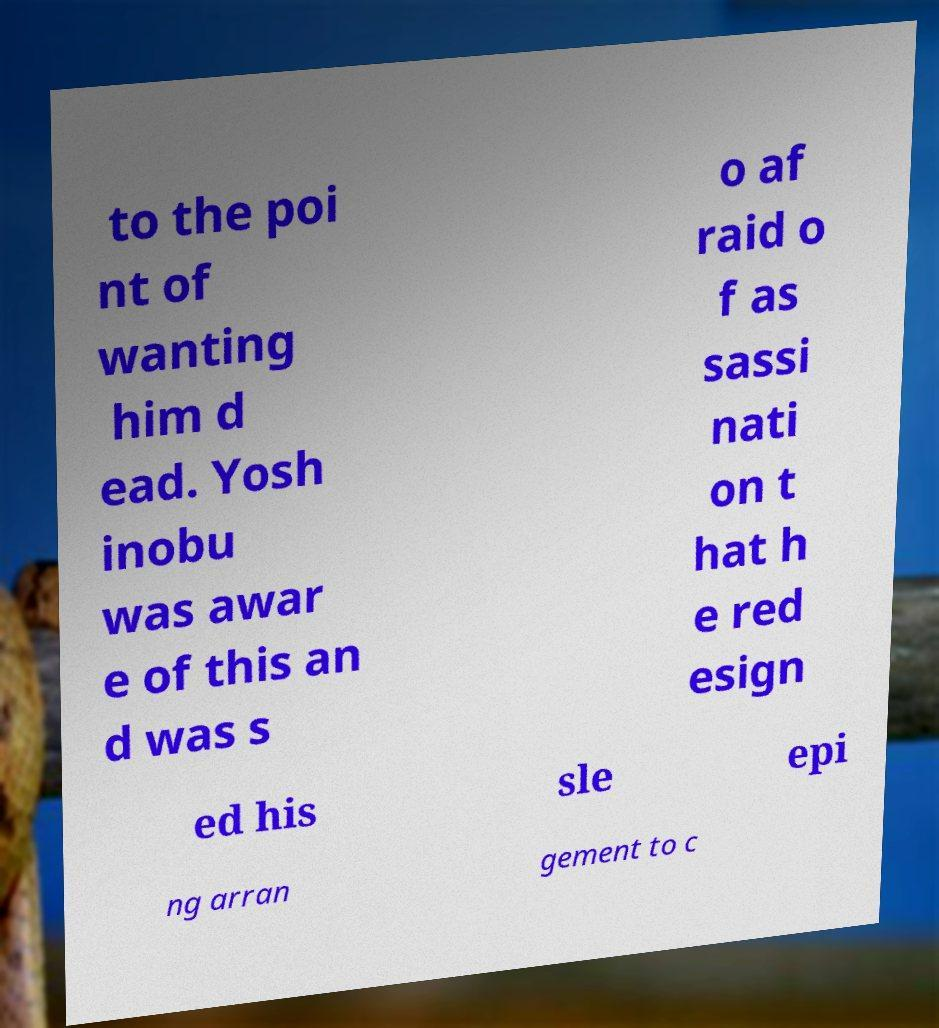Please read and relay the text visible in this image. What does it say? to the poi nt of wanting him d ead. Yosh inobu was awar e of this an d was s o af raid o f as sassi nati on t hat h e red esign ed his sle epi ng arran gement to c 